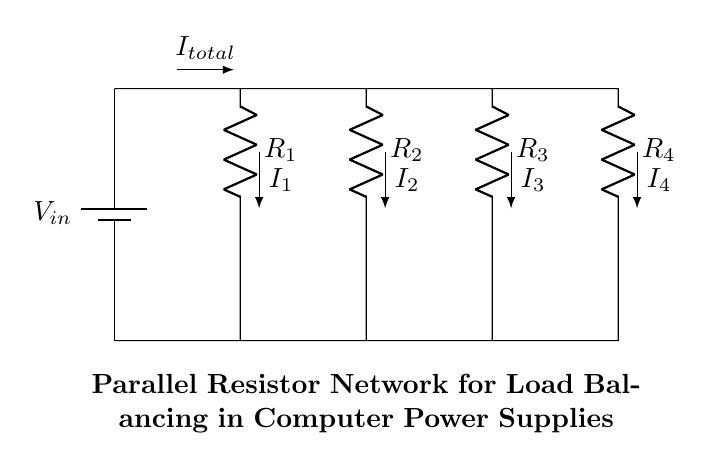What is the total current in the circuit? The total current, denoted as I_total, enters from the power supply and splits among the parallel resistors. This current can be measured or calculated based on the circuit's values, but it's labeled in the diagram.
Answer: I_total What component is used for load balancing? The parallel resistors (R2, R3, R4) in the circuit allow for equal sharing of the total current, leading to effective load balancing.
Answer: Parallel resistors How many resistors are in parallel? The diagram shows three resistors (R2, R3, and R4) connected in parallel after the main resistor.
Answer: Three What is the relationship between the currents? The currents through the parallel resistors are inversely proportional to their resistances, meaning that the resistor with the lowest resistance will have the highest current. This concept is derived from the current divider rule.
Answer: Inversely proportional How does the total resistance change when resistors are added? Adding more resistors in parallel decreases the total resistance, as the formula for total resistance in parallel shows that the inverse of the total resistance is the sum of the inverses of each resistor. Thus, the effective resistance of the circuit can be calculated and will always be less than the smallest resistance in parallel.
Answer: Decreases 